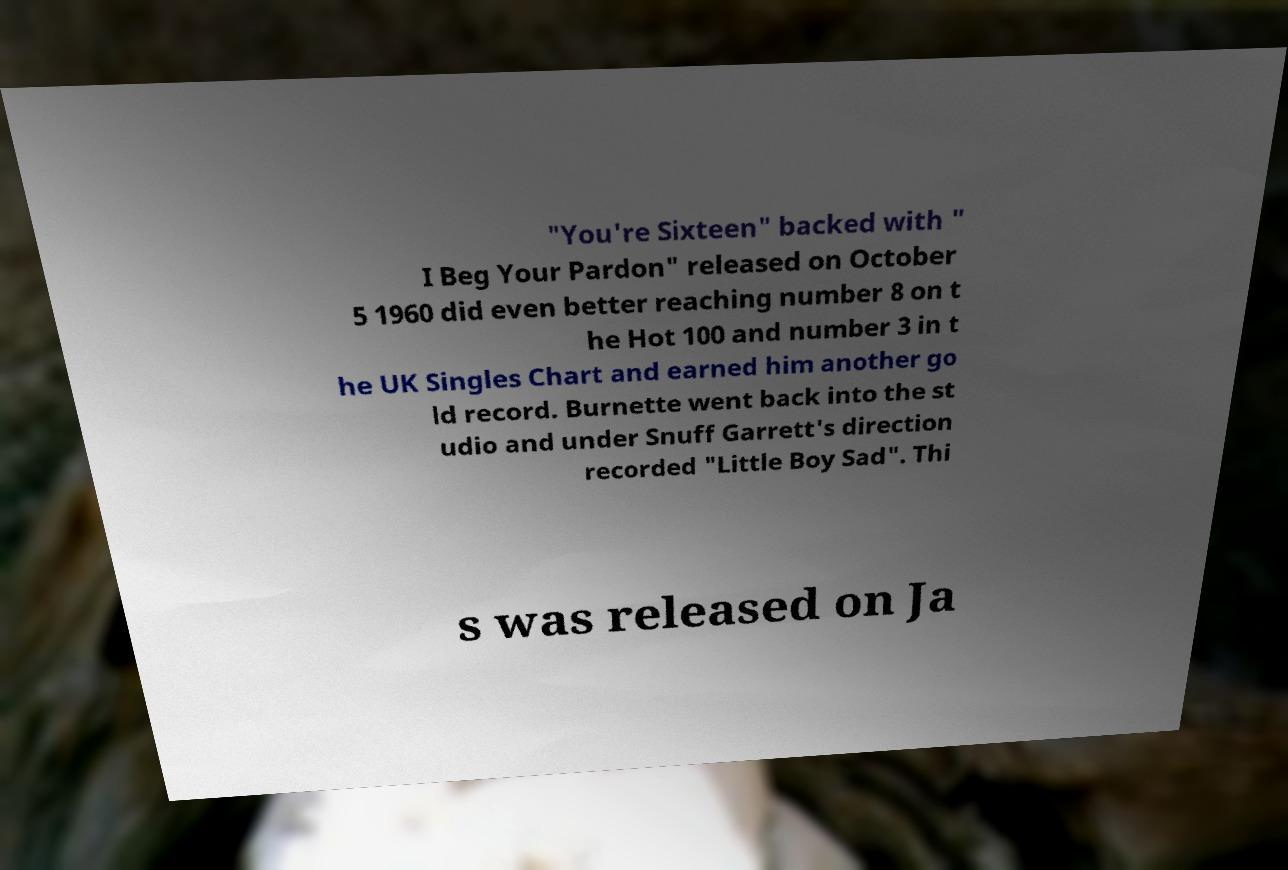Please read and relay the text visible in this image. What does it say? "You're Sixteen" backed with " I Beg Your Pardon" released on October 5 1960 did even better reaching number 8 on t he Hot 100 and number 3 in t he UK Singles Chart and earned him another go ld record. Burnette went back into the st udio and under Snuff Garrett's direction recorded "Little Boy Sad". Thi s was released on Ja 